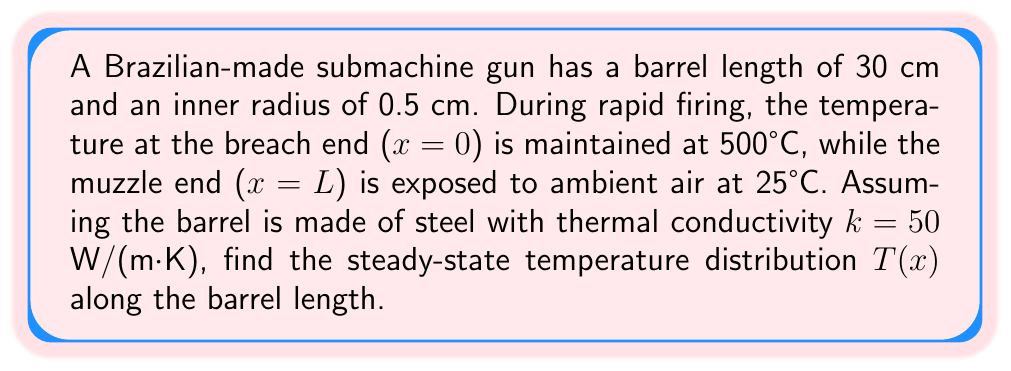Could you help me with this problem? To solve this problem, we'll use the steady-state heat equation in one dimension:

$$\frac{d^2T}{dx^2} = 0$$

With boundary conditions:
T(0) = 500°C (breach end)
T(L) = 25°C (muzzle end)

Step 1: The general solution to this equation is:
$$T(x) = Ax + B$$

Step 2: Apply boundary conditions:
At x = 0: $500 = B$
At x = L: $25 = AL + 500$

Step 3: Solve for A:
$$A = \frac{25 - 500}{L} = -\frac{475}{0.3} = -1583.33$$

Step 4: The final temperature distribution is:
$$T(x) = -1583.33x + 500$$

This linear distribution shows that the temperature decreases steadily from the breach to the muzzle.

Step 5: To verify, we can calculate the heat flux using Fourier's law:
$$q = -k\frac{dT}{dx} = -50 \cdot (-1583.33) = 79166.67 \text{ W/m}^2$$

This positive heat flux indicates heat flow from the breach to the muzzle, as expected.
Answer: $T(x) = -1583.33x + 500$ (°C) 